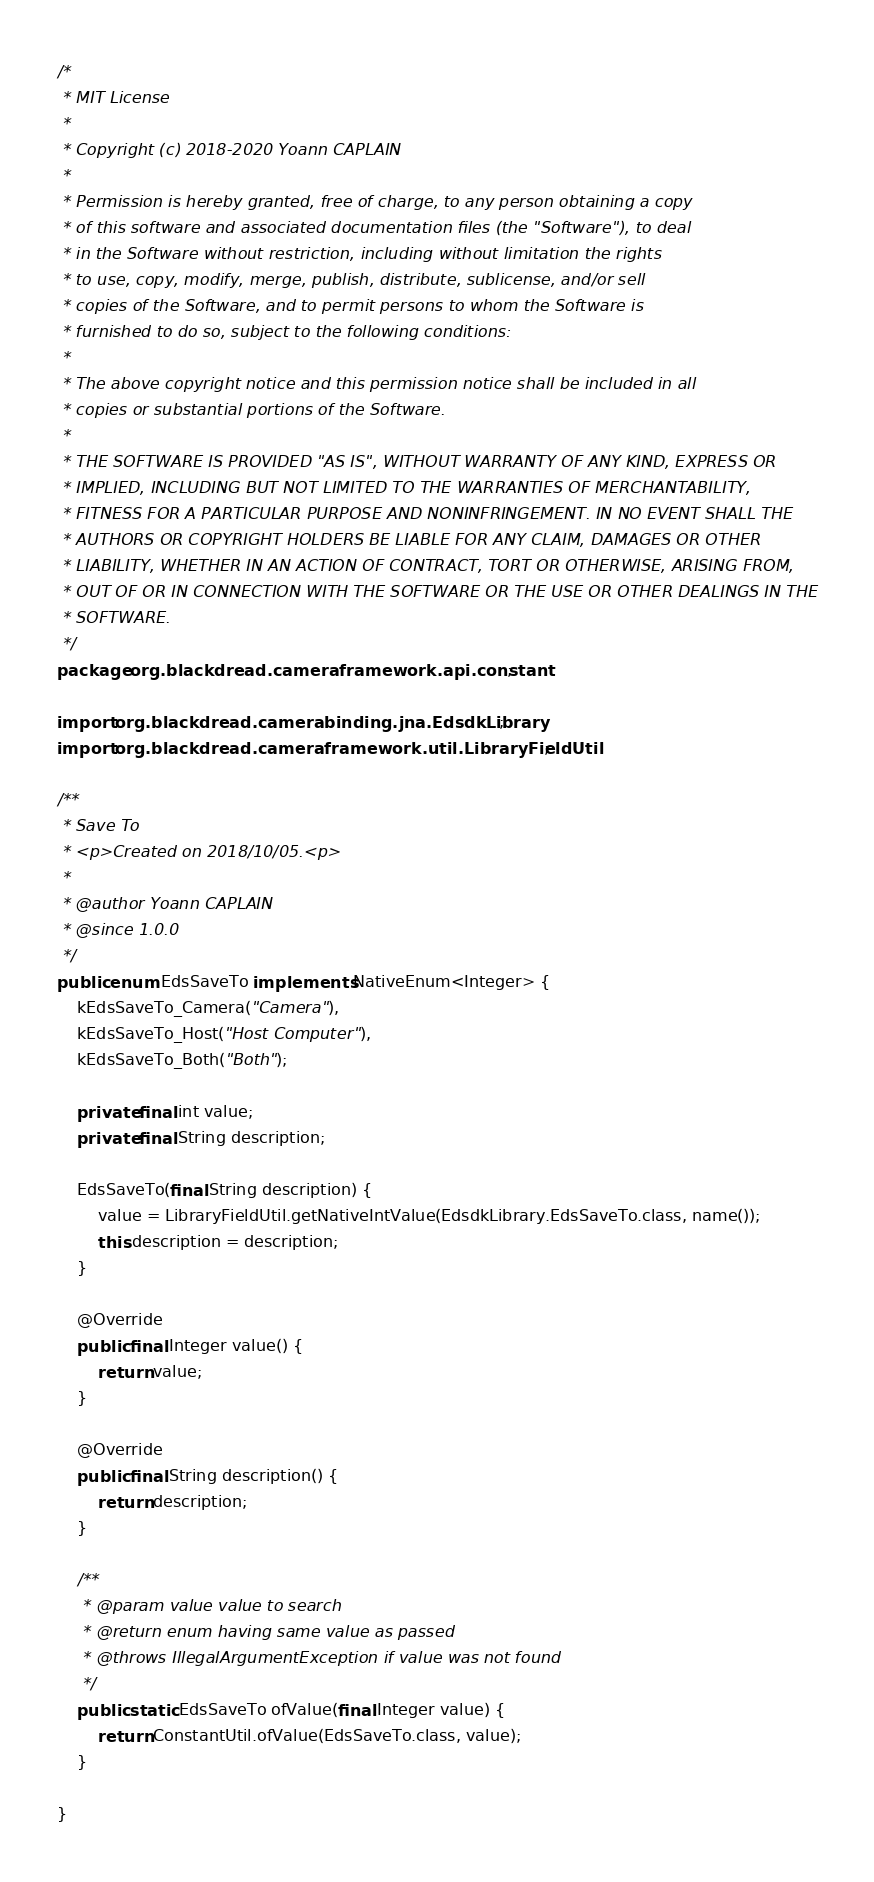<code> <loc_0><loc_0><loc_500><loc_500><_Java_>/*
 * MIT License
 *
 * Copyright (c) 2018-2020 Yoann CAPLAIN
 *
 * Permission is hereby granted, free of charge, to any person obtaining a copy
 * of this software and associated documentation files (the "Software"), to deal
 * in the Software without restriction, including without limitation the rights
 * to use, copy, modify, merge, publish, distribute, sublicense, and/or sell
 * copies of the Software, and to permit persons to whom the Software is
 * furnished to do so, subject to the following conditions:
 *
 * The above copyright notice and this permission notice shall be included in all
 * copies or substantial portions of the Software.
 *
 * THE SOFTWARE IS PROVIDED "AS IS", WITHOUT WARRANTY OF ANY KIND, EXPRESS OR
 * IMPLIED, INCLUDING BUT NOT LIMITED TO THE WARRANTIES OF MERCHANTABILITY,
 * FITNESS FOR A PARTICULAR PURPOSE AND NONINFRINGEMENT. IN NO EVENT SHALL THE
 * AUTHORS OR COPYRIGHT HOLDERS BE LIABLE FOR ANY CLAIM, DAMAGES OR OTHER
 * LIABILITY, WHETHER IN AN ACTION OF CONTRACT, TORT OR OTHERWISE, ARISING FROM,
 * OUT OF OR IN CONNECTION WITH THE SOFTWARE OR THE USE OR OTHER DEALINGS IN THE
 * SOFTWARE.
 */
package org.blackdread.cameraframework.api.constant;

import org.blackdread.camerabinding.jna.EdsdkLibrary;
import org.blackdread.cameraframework.util.LibraryFieldUtil;

/**
 * Save To
 * <p>Created on 2018/10/05.<p>
 *
 * @author Yoann CAPLAIN
 * @since 1.0.0
 */
public enum EdsSaveTo implements NativeEnum<Integer> {
    kEdsSaveTo_Camera("Camera"),
    kEdsSaveTo_Host("Host Computer"),
    kEdsSaveTo_Both("Both");

    private final int value;
    private final String description;

    EdsSaveTo(final String description) {
        value = LibraryFieldUtil.getNativeIntValue(EdsdkLibrary.EdsSaveTo.class, name());
        this.description = description;
    }

    @Override
    public final Integer value() {
        return value;
    }

    @Override
    public final String description() {
        return description;
    }

    /**
     * @param value value to search
     * @return enum having same value as passed
     * @throws IllegalArgumentException if value was not found
     */
    public static EdsSaveTo ofValue(final Integer value) {
        return ConstantUtil.ofValue(EdsSaveTo.class, value);
    }

}
</code> 